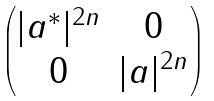<formula> <loc_0><loc_0><loc_500><loc_500>\begin{pmatrix} | a ^ { * } | ^ { 2 n } & 0 \\ 0 & | a | ^ { 2 n } \end{pmatrix}</formula> 